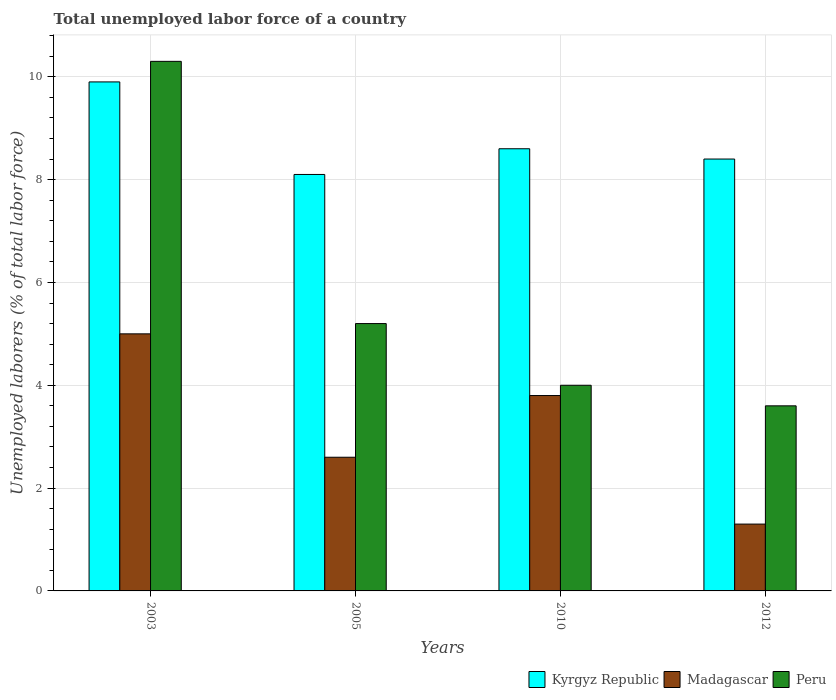How many different coloured bars are there?
Provide a succinct answer. 3. How many groups of bars are there?
Provide a succinct answer. 4. What is the label of the 4th group of bars from the left?
Your answer should be very brief. 2012. In how many cases, is the number of bars for a given year not equal to the number of legend labels?
Your answer should be very brief. 0. Across all years, what is the maximum total unemployed labor force in Peru?
Give a very brief answer. 10.3. Across all years, what is the minimum total unemployed labor force in Peru?
Ensure brevity in your answer.  3.6. In which year was the total unemployed labor force in Peru minimum?
Offer a very short reply. 2012. What is the total total unemployed labor force in Peru in the graph?
Your answer should be compact. 23.1. What is the difference between the total unemployed labor force in Kyrgyz Republic in 2005 and that in 2012?
Your answer should be compact. -0.3. What is the difference between the total unemployed labor force in Kyrgyz Republic in 2005 and the total unemployed labor force in Peru in 2012?
Your answer should be very brief. 4.5. What is the average total unemployed labor force in Kyrgyz Republic per year?
Your answer should be very brief. 8.75. In the year 2012, what is the difference between the total unemployed labor force in Madagascar and total unemployed labor force in Peru?
Your answer should be very brief. -2.3. In how many years, is the total unemployed labor force in Madagascar greater than 9.2 %?
Offer a terse response. 0. What is the ratio of the total unemployed labor force in Peru in 2005 to that in 2010?
Provide a succinct answer. 1.3. Is the difference between the total unemployed labor force in Madagascar in 2003 and 2012 greater than the difference between the total unemployed labor force in Peru in 2003 and 2012?
Provide a succinct answer. No. What is the difference between the highest and the second highest total unemployed labor force in Peru?
Provide a short and direct response. 5.1. What is the difference between the highest and the lowest total unemployed labor force in Kyrgyz Republic?
Your answer should be very brief. 1.8. In how many years, is the total unemployed labor force in Madagascar greater than the average total unemployed labor force in Madagascar taken over all years?
Ensure brevity in your answer.  2. Is the sum of the total unemployed labor force in Peru in 2003 and 2010 greater than the maximum total unemployed labor force in Madagascar across all years?
Offer a terse response. Yes. What does the 3rd bar from the left in 2012 represents?
Give a very brief answer. Peru. What does the 2nd bar from the right in 2010 represents?
Your answer should be compact. Madagascar. How many bars are there?
Your response must be concise. 12. How many years are there in the graph?
Make the answer very short. 4. Are the values on the major ticks of Y-axis written in scientific E-notation?
Your answer should be very brief. No. Does the graph contain grids?
Your response must be concise. Yes. Where does the legend appear in the graph?
Your answer should be compact. Bottom right. How many legend labels are there?
Provide a succinct answer. 3. How are the legend labels stacked?
Give a very brief answer. Horizontal. What is the title of the graph?
Make the answer very short. Total unemployed labor force of a country. Does "Latin America(developing only)" appear as one of the legend labels in the graph?
Provide a short and direct response. No. What is the label or title of the Y-axis?
Keep it short and to the point. Unemployed laborers (% of total labor force). What is the Unemployed laborers (% of total labor force) in Kyrgyz Republic in 2003?
Offer a very short reply. 9.9. What is the Unemployed laborers (% of total labor force) of Peru in 2003?
Ensure brevity in your answer.  10.3. What is the Unemployed laborers (% of total labor force) in Kyrgyz Republic in 2005?
Your response must be concise. 8.1. What is the Unemployed laborers (% of total labor force) in Madagascar in 2005?
Your answer should be very brief. 2.6. What is the Unemployed laborers (% of total labor force) of Peru in 2005?
Give a very brief answer. 5.2. What is the Unemployed laborers (% of total labor force) of Kyrgyz Republic in 2010?
Offer a terse response. 8.6. What is the Unemployed laborers (% of total labor force) of Madagascar in 2010?
Your response must be concise. 3.8. What is the Unemployed laborers (% of total labor force) of Kyrgyz Republic in 2012?
Make the answer very short. 8.4. What is the Unemployed laborers (% of total labor force) in Madagascar in 2012?
Your answer should be very brief. 1.3. What is the Unemployed laborers (% of total labor force) of Peru in 2012?
Your answer should be compact. 3.6. Across all years, what is the maximum Unemployed laborers (% of total labor force) in Kyrgyz Republic?
Offer a very short reply. 9.9. Across all years, what is the maximum Unemployed laborers (% of total labor force) of Madagascar?
Your answer should be very brief. 5. Across all years, what is the maximum Unemployed laborers (% of total labor force) of Peru?
Keep it short and to the point. 10.3. Across all years, what is the minimum Unemployed laborers (% of total labor force) of Kyrgyz Republic?
Keep it short and to the point. 8.1. Across all years, what is the minimum Unemployed laborers (% of total labor force) in Madagascar?
Your response must be concise. 1.3. Across all years, what is the minimum Unemployed laborers (% of total labor force) in Peru?
Keep it short and to the point. 3.6. What is the total Unemployed laborers (% of total labor force) of Kyrgyz Republic in the graph?
Offer a very short reply. 35. What is the total Unemployed laborers (% of total labor force) in Peru in the graph?
Your response must be concise. 23.1. What is the difference between the Unemployed laborers (% of total labor force) of Kyrgyz Republic in 2003 and that in 2005?
Your answer should be compact. 1.8. What is the difference between the Unemployed laborers (% of total labor force) of Madagascar in 2003 and that in 2005?
Give a very brief answer. 2.4. What is the difference between the Unemployed laborers (% of total labor force) of Peru in 2003 and that in 2005?
Your answer should be compact. 5.1. What is the difference between the Unemployed laborers (% of total labor force) in Peru in 2003 and that in 2010?
Your answer should be compact. 6.3. What is the difference between the Unemployed laborers (% of total labor force) of Madagascar in 2003 and that in 2012?
Your response must be concise. 3.7. What is the difference between the Unemployed laborers (% of total labor force) in Madagascar in 2005 and that in 2010?
Make the answer very short. -1.2. What is the difference between the Unemployed laborers (% of total labor force) of Kyrgyz Republic in 2003 and the Unemployed laborers (% of total labor force) of Peru in 2005?
Provide a succinct answer. 4.7. What is the difference between the Unemployed laborers (% of total labor force) in Madagascar in 2003 and the Unemployed laborers (% of total labor force) in Peru in 2005?
Provide a succinct answer. -0.2. What is the difference between the Unemployed laborers (% of total labor force) of Kyrgyz Republic in 2003 and the Unemployed laborers (% of total labor force) of Peru in 2010?
Offer a very short reply. 5.9. What is the difference between the Unemployed laborers (% of total labor force) in Madagascar in 2003 and the Unemployed laborers (% of total labor force) in Peru in 2010?
Offer a very short reply. 1. What is the difference between the Unemployed laborers (% of total labor force) of Kyrgyz Republic in 2003 and the Unemployed laborers (% of total labor force) of Peru in 2012?
Your response must be concise. 6.3. What is the difference between the Unemployed laborers (% of total labor force) of Madagascar in 2003 and the Unemployed laborers (% of total labor force) of Peru in 2012?
Offer a very short reply. 1.4. What is the difference between the Unemployed laborers (% of total labor force) in Kyrgyz Republic in 2005 and the Unemployed laborers (% of total labor force) in Madagascar in 2010?
Your answer should be compact. 4.3. What is the difference between the Unemployed laborers (% of total labor force) in Madagascar in 2005 and the Unemployed laborers (% of total labor force) in Peru in 2012?
Make the answer very short. -1. What is the difference between the Unemployed laborers (% of total labor force) in Kyrgyz Republic in 2010 and the Unemployed laborers (% of total labor force) in Madagascar in 2012?
Offer a very short reply. 7.3. What is the difference between the Unemployed laborers (% of total labor force) of Kyrgyz Republic in 2010 and the Unemployed laborers (% of total labor force) of Peru in 2012?
Your answer should be very brief. 5. What is the difference between the Unemployed laborers (% of total labor force) of Madagascar in 2010 and the Unemployed laborers (% of total labor force) of Peru in 2012?
Offer a terse response. 0.2. What is the average Unemployed laborers (% of total labor force) in Kyrgyz Republic per year?
Provide a succinct answer. 8.75. What is the average Unemployed laborers (% of total labor force) of Madagascar per year?
Ensure brevity in your answer.  3.17. What is the average Unemployed laborers (% of total labor force) of Peru per year?
Provide a succinct answer. 5.78. In the year 2003, what is the difference between the Unemployed laborers (% of total labor force) in Kyrgyz Republic and Unemployed laborers (% of total labor force) in Madagascar?
Offer a terse response. 4.9. In the year 2003, what is the difference between the Unemployed laborers (% of total labor force) in Madagascar and Unemployed laborers (% of total labor force) in Peru?
Give a very brief answer. -5.3. In the year 2005, what is the difference between the Unemployed laborers (% of total labor force) in Madagascar and Unemployed laborers (% of total labor force) in Peru?
Your answer should be compact. -2.6. In the year 2010, what is the difference between the Unemployed laborers (% of total labor force) of Kyrgyz Republic and Unemployed laborers (% of total labor force) of Madagascar?
Give a very brief answer. 4.8. In the year 2012, what is the difference between the Unemployed laborers (% of total labor force) of Kyrgyz Republic and Unemployed laborers (% of total labor force) of Madagascar?
Ensure brevity in your answer.  7.1. In the year 2012, what is the difference between the Unemployed laborers (% of total labor force) in Kyrgyz Republic and Unemployed laborers (% of total labor force) in Peru?
Your answer should be very brief. 4.8. What is the ratio of the Unemployed laborers (% of total labor force) of Kyrgyz Republic in 2003 to that in 2005?
Make the answer very short. 1.22. What is the ratio of the Unemployed laborers (% of total labor force) in Madagascar in 2003 to that in 2005?
Your answer should be compact. 1.92. What is the ratio of the Unemployed laborers (% of total labor force) in Peru in 2003 to that in 2005?
Offer a terse response. 1.98. What is the ratio of the Unemployed laborers (% of total labor force) of Kyrgyz Republic in 2003 to that in 2010?
Ensure brevity in your answer.  1.15. What is the ratio of the Unemployed laborers (% of total labor force) of Madagascar in 2003 to that in 2010?
Your answer should be compact. 1.32. What is the ratio of the Unemployed laborers (% of total labor force) in Peru in 2003 to that in 2010?
Keep it short and to the point. 2.58. What is the ratio of the Unemployed laborers (% of total labor force) of Kyrgyz Republic in 2003 to that in 2012?
Your answer should be compact. 1.18. What is the ratio of the Unemployed laborers (% of total labor force) of Madagascar in 2003 to that in 2012?
Provide a succinct answer. 3.85. What is the ratio of the Unemployed laborers (% of total labor force) of Peru in 2003 to that in 2012?
Provide a succinct answer. 2.86. What is the ratio of the Unemployed laborers (% of total labor force) of Kyrgyz Republic in 2005 to that in 2010?
Your response must be concise. 0.94. What is the ratio of the Unemployed laborers (% of total labor force) in Madagascar in 2005 to that in 2010?
Give a very brief answer. 0.68. What is the ratio of the Unemployed laborers (% of total labor force) in Peru in 2005 to that in 2010?
Your answer should be compact. 1.3. What is the ratio of the Unemployed laborers (% of total labor force) of Kyrgyz Republic in 2005 to that in 2012?
Your answer should be compact. 0.96. What is the ratio of the Unemployed laborers (% of total labor force) of Madagascar in 2005 to that in 2012?
Provide a short and direct response. 2. What is the ratio of the Unemployed laborers (% of total labor force) in Peru in 2005 to that in 2012?
Provide a succinct answer. 1.44. What is the ratio of the Unemployed laborers (% of total labor force) of Kyrgyz Republic in 2010 to that in 2012?
Provide a short and direct response. 1.02. What is the ratio of the Unemployed laborers (% of total labor force) in Madagascar in 2010 to that in 2012?
Offer a very short reply. 2.92. What is the ratio of the Unemployed laborers (% of total labor force) in Peru in 2010 to that in 2012?
Your answer should be very brief. 1.11. What is the difference between the highest and the second highest Unemployed laborers (% of total labor force) in Kyrgyz Republic?
Offer a very short reply. 1.3. 